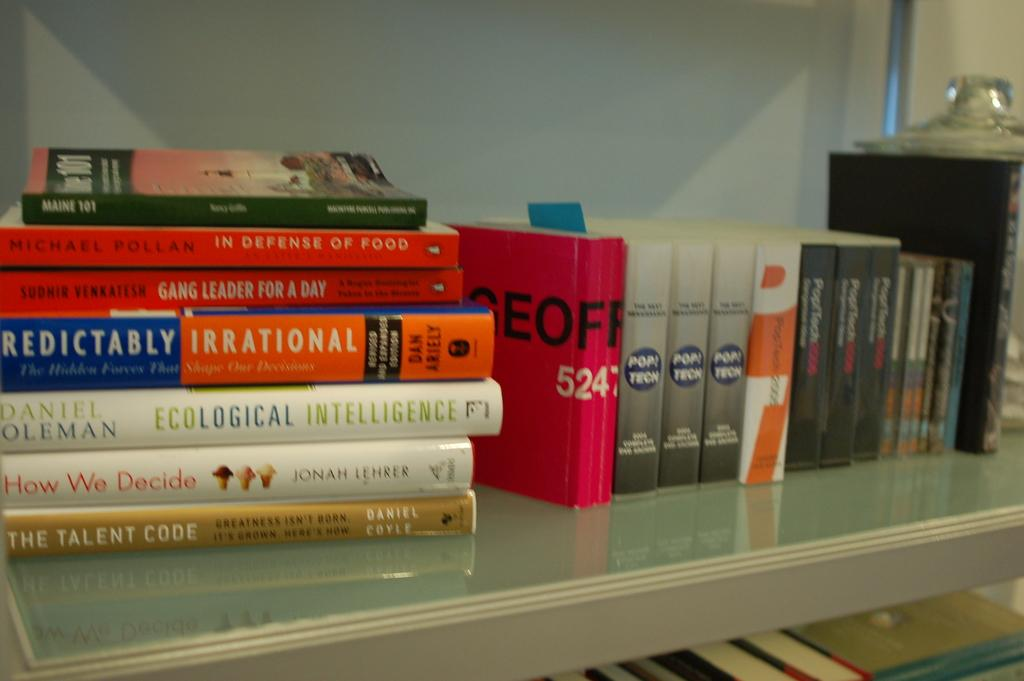Provide a one-sentence caption for the provided image. a book with the words talent code at the end. 